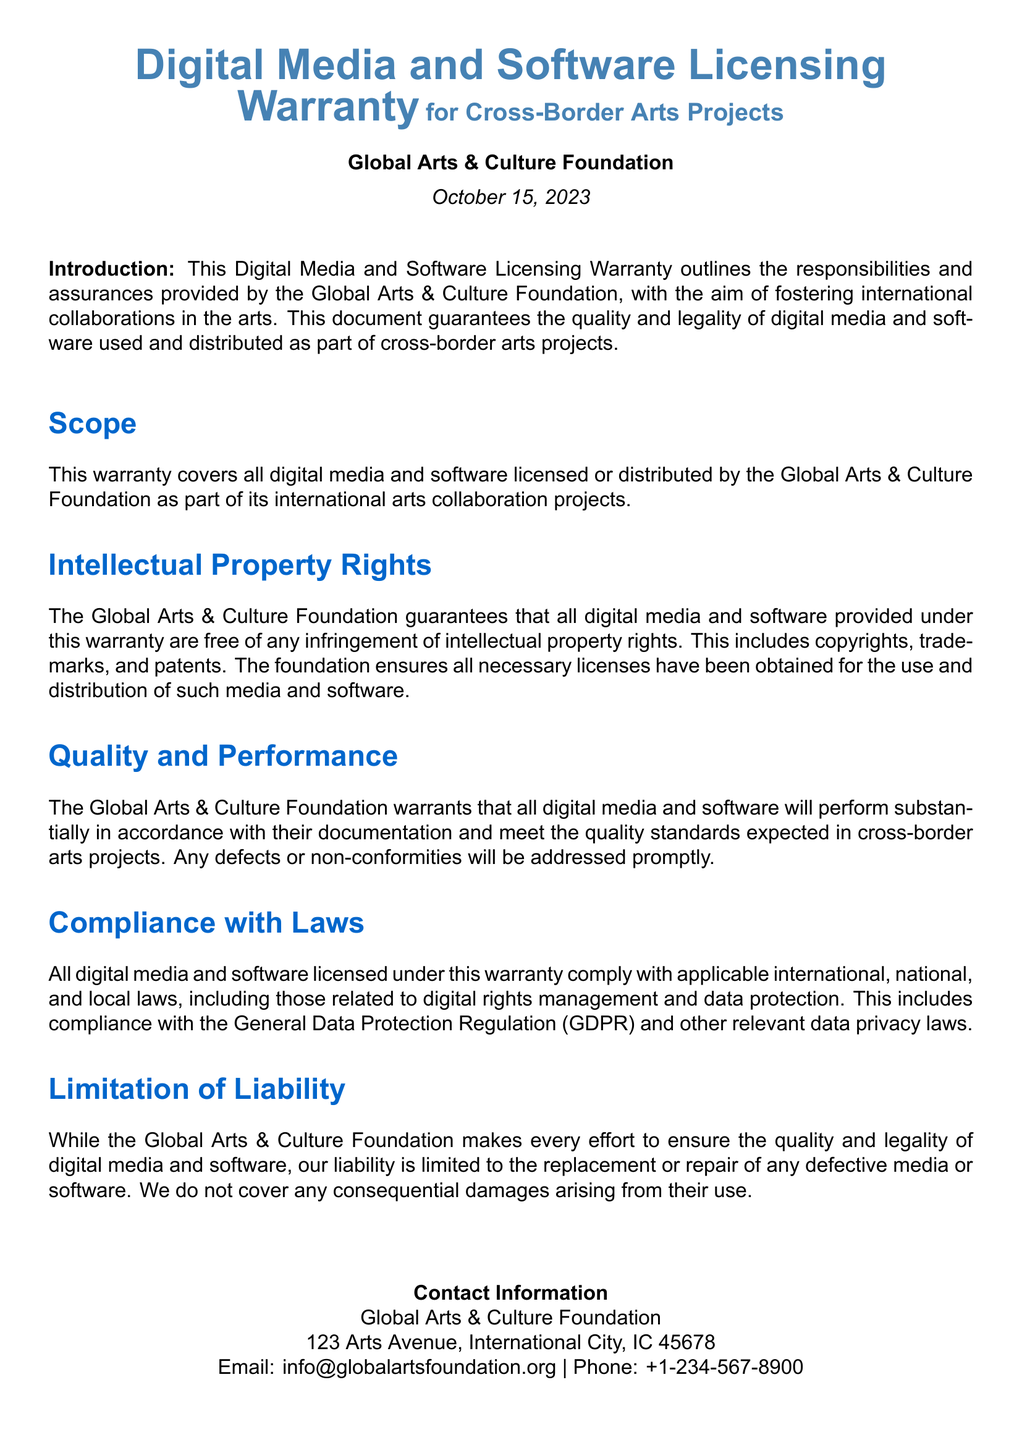What is the title of the document? The title is clearly stated at the top of the document.
Answer: Digital Media and Software Licensing Warranty What is the date of publication? The publication date is mentioned in the document.
Answer: October 15, 2023 Who is the authoring organization? The organization responsible for the document is identified in the introduction.
Answer: Global Arts & Culture Foundation What type of rights are guaranteed to be free of infringement? The section on Intellectual Property Rights specifies the types of rights covered.
Answer: Intellectual Property Rights What does the warranty cover? The Scope section outlines what is included in the warranty.
Answer: All digital media and software What is the limitation of liability? The Limitation of Liability section describes the extent of liability of the foundation.
Answer: Replacement or repair of any defective media or software What laws must the digital media and software comply with? The Compliance with Laws section lists important regulations.
Answer: Applicable international, national, and local laws When addressing defects, what action will the foundation take? The document mentions the response to non-conformities and defects.
Answer: Addressed promptly 